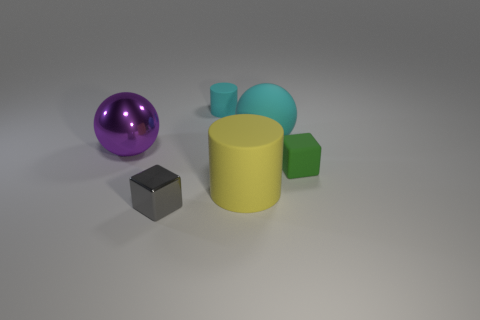How many cylinders are either large brown things or small green rubber things?
Provide a succinct answer. 0. What number of cylinders are behind the cylinder that is behind the large sphere that is to the left of the tiny cylinder?
Keep it short and to the point. 0. There is another thing that is the same shape as the gray thing; what is its material?
Your response must be concise. Rubber. There is a large sphere right of the purple shiny thing; what is its color?
Give a very brief answer. Cyan. Do the big yellow thing and the small block in front of the large yellow rubber object have the same material?
Keep it short and to the point. No. What is the material of the tiny green object?
Your response must be concise. Rubber. What is the shape of the tiny green object that is the same material as the tiny cylinder?
Keep it short and to the point. Cube. What number of large purple balls are in front of the large matte sphere?
Your response must be concise. 1. There is a block that is left of the tiny green rubber cube; does it have the same size as the matte thing that is in front of the small green matte object?
Provide a short and direct response. No. What number of other objects are the same size as the gray metallic object?
Give a very brief answer. 2. 